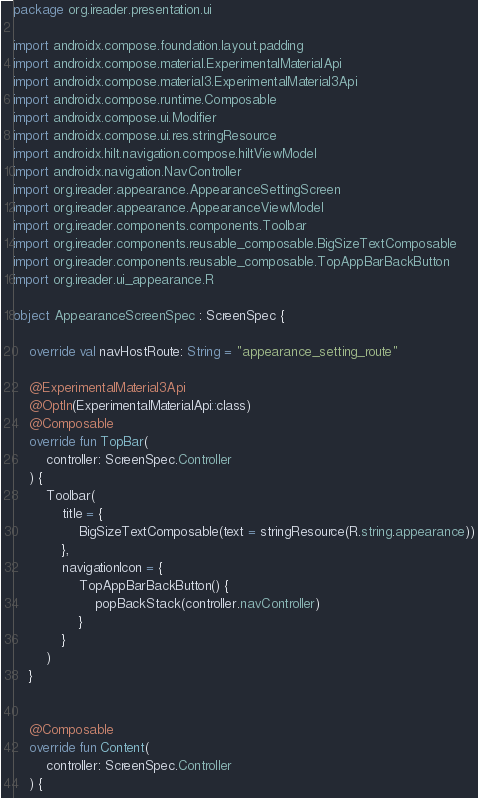<code> <loc_0><loc_0><loc_500><loc_500><_Kotlin_>package org.ireader.presentation.ui

import androidx.compose.foundation.layout.padding
import androidx.compose.material.ExperimentalMaterialApi
import androidx.compose.material3.ExperimentalMaterial3Api
import androidx.compose.runtime.Composable
import androidx.compose.ui.Modifier
import androidx.compose.ui.res.stringResource
import androidx.hilt.navigation.compose.hiltViewModel
import androidx.navigation.NavController
import org.ireader.appearance.AppearanceSettingScreen
import org.ireader.appearance.AppearanceViewModel
import org.ireader.components.components.Toolbar
import org.ireader.components.reusable_composable.BigSizeTextComposable
import org.ireader.components.reusable_composable.TopAppBarBackButton
import org.ireader.ui_appearance.R

object AppearanceScreenSpec : ScreenSpec {

    override val navHostRoute: String = "appearance_setting_route"

    @ExperimentalMaterial3Api
    @OptIn(ExperimentalMaterialApi::class)
    @Composable
    override fun TopBar(
        controller: ScreenSpec.Controller
    ) {
        Toolbar(
            title = {
                BigSizeTextComposable(text = stringResource(R.string.appearance))
            },
            navigationIcon = {
                TopAppBarBackButton() {
                    popBackStack(controller.navController)
                }
            }
        )
    }


    @Composable
    override fun Content(
        controller: ScreenSpec.Controller
    ) {</code> 